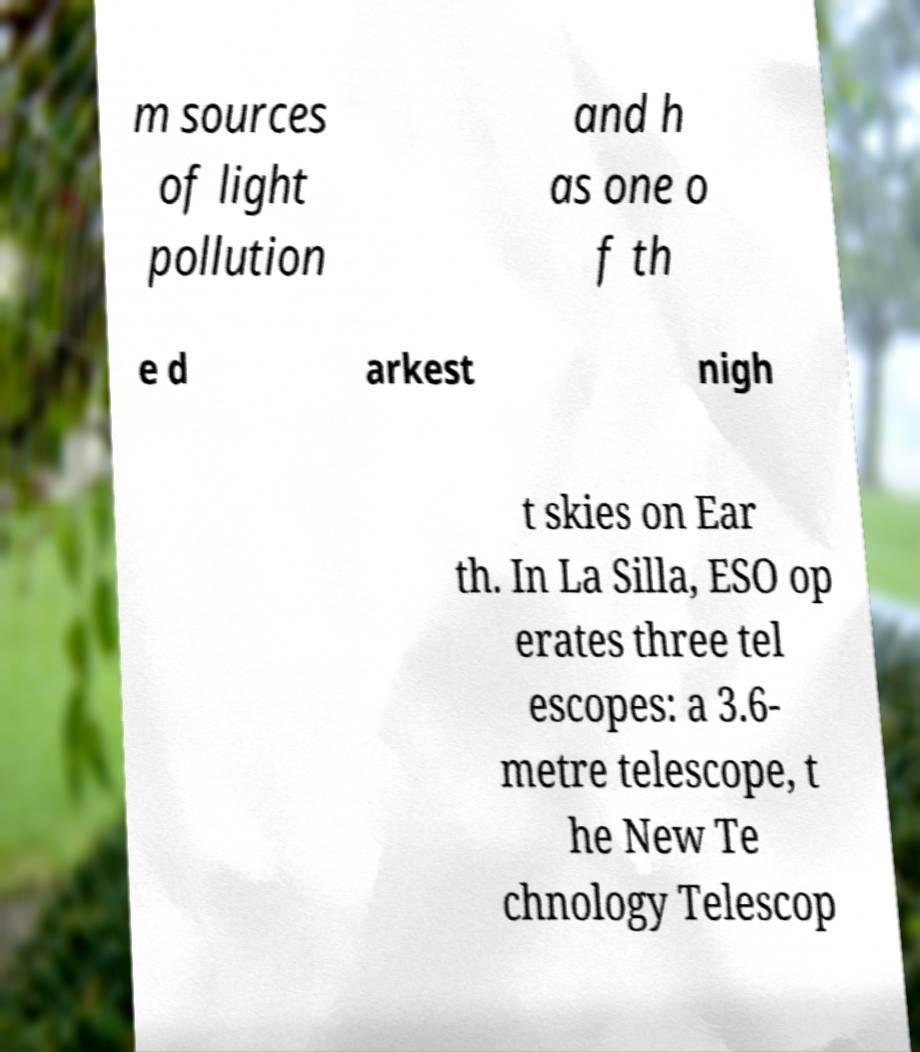Could you assist in decoding the text presented in this image and type it out clearly? m sources of light pollution and h as one o f th e d arkest nigh t skies on Ear th. In La Silla, ESO op erates three tel escopes: a 3.6- metre telescope, t he New Te chnology Telescop 